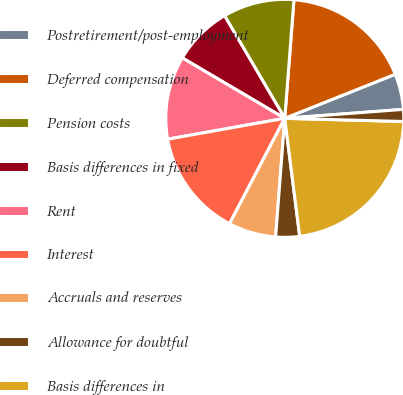Convert chart. <chart><loc_0><loc_0><loc_500><loc_500><pie_chart><fcel>Postretirement/post-employment<fcel>Deferred compensation<fcel>Pension costs<fcel>Basis differences in fixed<fcel>Rent<fcel>Interest<fcel>Accruals and reserves<fcel>Allowance for doubtful<fcel>Basis differences in<fcel>Investments in equity<nl><fcel>4.84%<fcel>17.73%<fcel>9.68%<fcel>8.07%<fcel>11.29%<fcel>14.51%<fcel>6.46%<fcel>3.23%<fcel>22.57%<fcel>1.62%<nl></chart> 